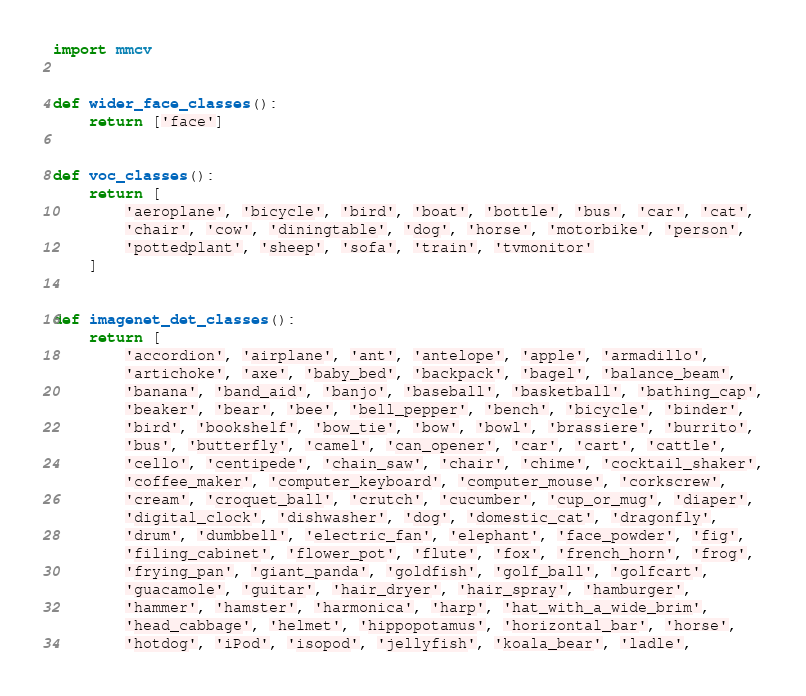Convert code to text. <code><loc_0><loc_0><loc_500><loc_500><_Python_>import mmcv


def wider_face_classes():
    return ['face']


def voc_classes():
    return [
        'aeroplane', 'bicycle', 'bird', 'boat', 'bottle', 'bus', 'car', 'cat',
        'chair', 'cow', 'diningtable', 'dog', 'horse', 'motorbike', 'person',
        'pottedplant', 'sheep', 'sofa', 'train', 'tvmonitor'
    ]


def imagenet_det_classes():
    return [
        'accordion', 'airplane', 'ant', 'antelope', 'apple', 'armadillo',
        'artichoke', 'axe', 'baby_bed', 'backpack', 'bagel', 'balance_beam',
        'banana', 'band_aid', 'banjo', 'baseball', 'basketball', 'bathing_cap',
        'beaker', 'bear', 'bee', 'bell_pepper', 'bench', 'bicycle', 'binder',
        'bird', 'bookshelf', 'bow_tie', 'bow', 'bowl', 'brassiere', 'burrito',
        'bus', 'butterfly', 'camel', 'can_opener', 'car', 'cart', 'cattle',
        'cello', 'centipede', 'chain_saw', 'chair', 'chime', 'cocktail_shaker',
        'coffee_maker', 'computer_keyboard', 'computer_mouse', 'corkscrew',
        'cream', 'croquet_ball', 'crutch', 'cucumber', 'cup_or_mug', 'diaper',
        'digital_clock', 'dishwasher', 'dog', 'domestic_cat', 'dragonfly',
        'drum', 'dumbbell', 'electric_fan', 'elephant', 'face_powder', 'fig',
        'filing_cabinet', 'flower_pot', 'flute', 'fox', 'french_horn', 'frog',
        'frying_pan', 'giant_panda', 'goldfish', 'golf_ball', 'golfcart',
        'guacamole', 'guitar', 'hair_dryer', 'hair_spray', 'hamburger',
        'hammer', 'hamster', 'harmonica', 'harp', 'hat_with_a_wide_brim',
        'head_cabbage', 'helmet', 'hippopotamus', 'horizontal_bar', 'horse',
        'hotdog', 'iPod', 'isopod', 'jellyfish', 'koala_bear', 'ladle',</code> 